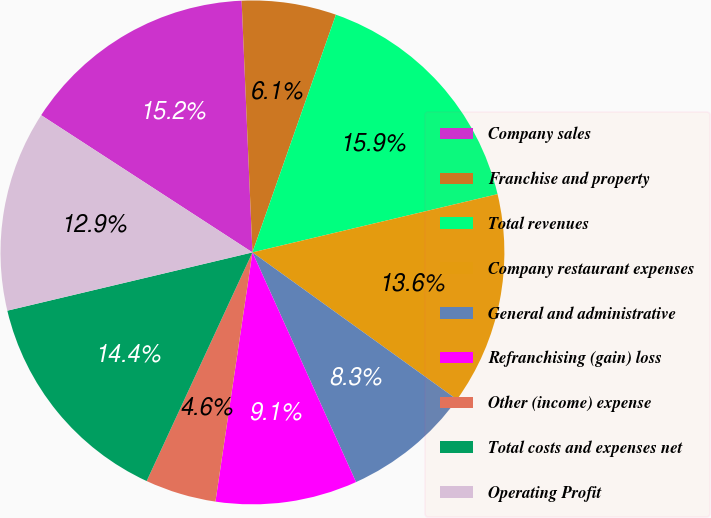<chart> <loc_0><loc_0><loc_500><loc_500><pie_chart><fcel>Company sales<fcel>Franchise and property<fcel>Total revenues<fcel>Company restaurant expenses<fcel>General and administrative<fcel>Refranchising (gain) loss<fcel>Other (income) expense<fcel>Total costs and expenses net<fcel>Operating Profit<nl><fcel>15.15%<fcel>6.06%<fcel>15.91%<fcel>13.64%<fcel>8.33%<fcel>9.09%<fcel>4.55%<fcel>14.39%<fcel>12.88%<nl></chart> 